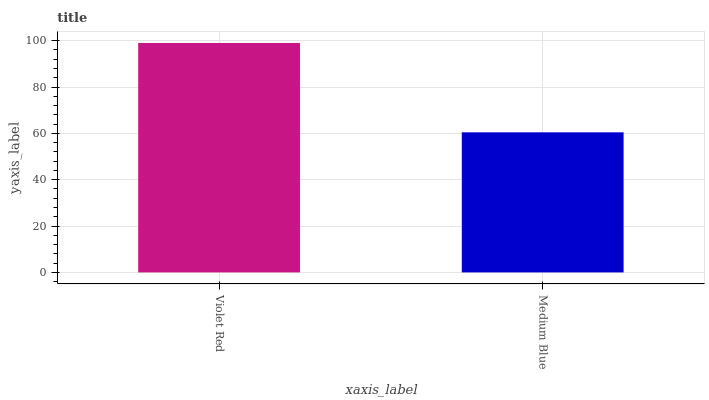Is Medium Blue the maximum?
Answer yes or no. No. Is Violet Red greater than Medium Blue?
Answer yes or no. Yes. Is Medium Blue less than Violet Red?
Answer yes or no. Yes. Is Medium Blue greater than Violet Red?
Answer yes or no. No. Is Violet Red less than Medium Blue?
Answer yes or no. No. Is Violet Red the high median?
Answer yes or no. Yes. Is Medium Blue the low median?
Answer yes or no. Yes. Is Medium Blue the high median?
Answer yes or no. No. Is Violet Red the low median?
Answer yes or no. No. 